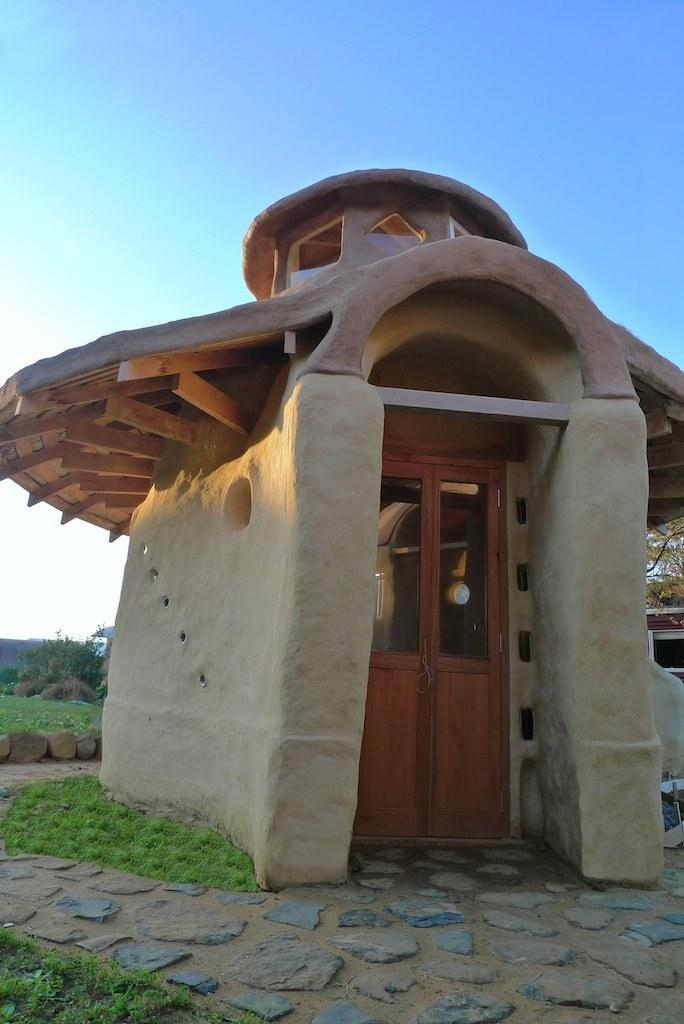What type of structure is in the image? There is a tiny house in the image. What feature is present on the house? There is a door on the house. What type of natural elements can be seen in the image? Stones, grass, trees, and the sky are visible in the image. What type of bear can be seen attending the meeting in the image? There is no meeting or bear present in the image. What type of turkey is visible in the image? There is no turkey present in the image. 